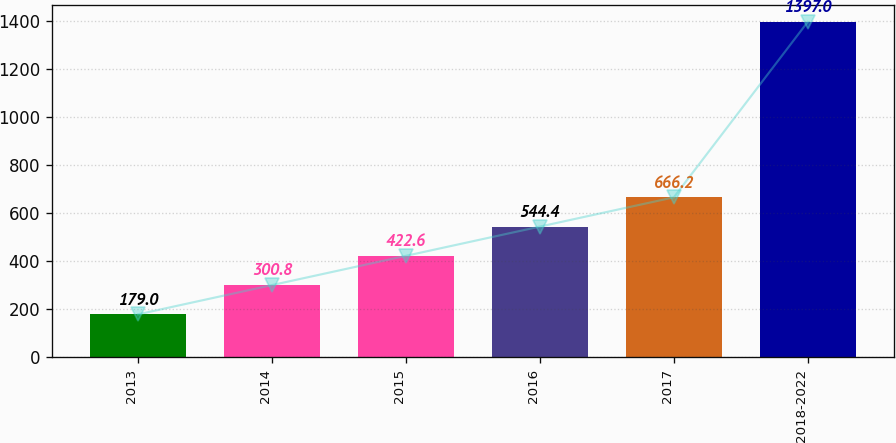Convert chart to OTSL. <chart><loc_0><loc_0><loc_500><loc_500><bar_chart><fcel>2013<fcel>2014<fcel>2015<fcel>2016<fcel>2017<fcel>2018-2022<nl><fcel>179<fcel>300.8<fcel>422.6<fcel>544.4<fcel>666.2<fcel>1397<nl></chart> 